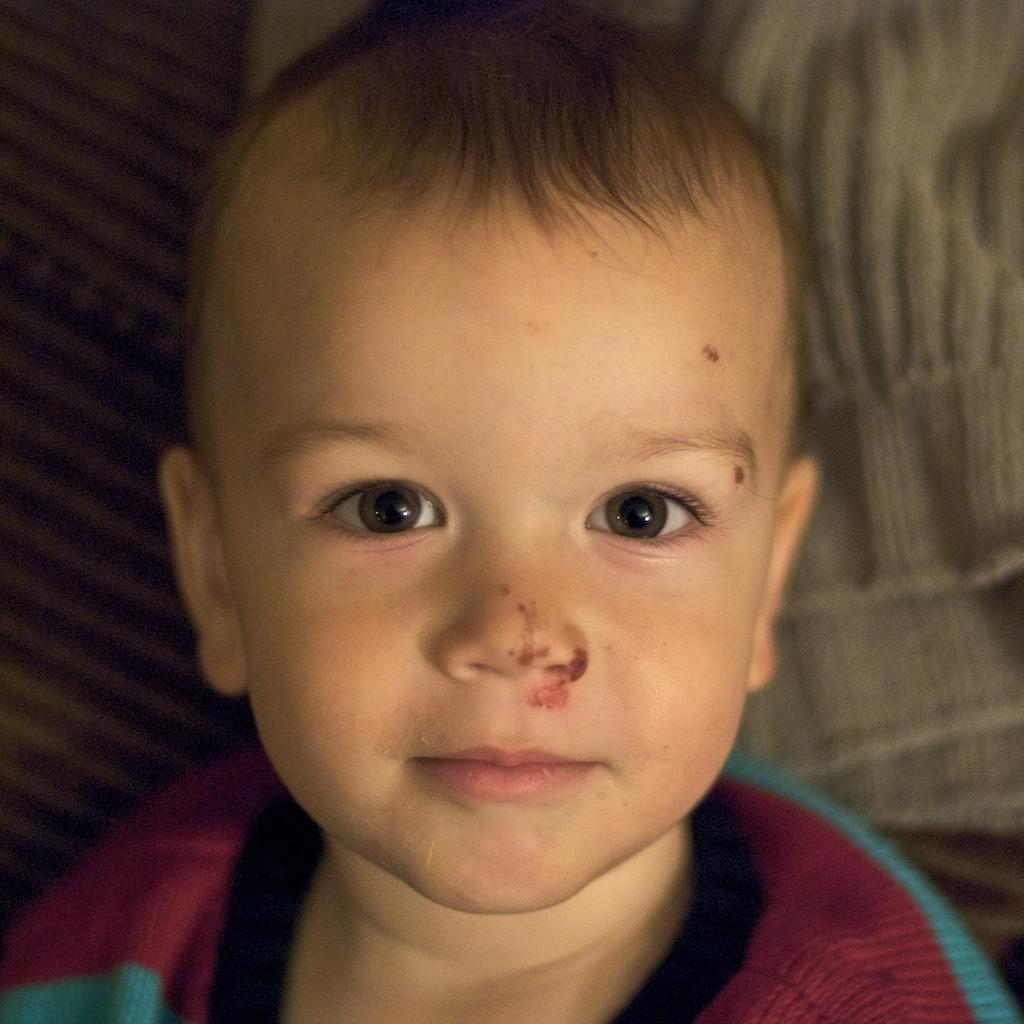Who is the main subject in the picture? There is a boy in the picture. What is the boy wearing? The boy is wearing a t-shirt. Can you describe the colors and patterns of the cloths in the image? There is an off-white color cloth at the back, and a black and off-white color striped cloth in the image. How does the boy fold the prose in the image? There is no mention of prose or folding in the image; it features a boy wearing a t-shirt and two cloths with specific colors and patterns. 